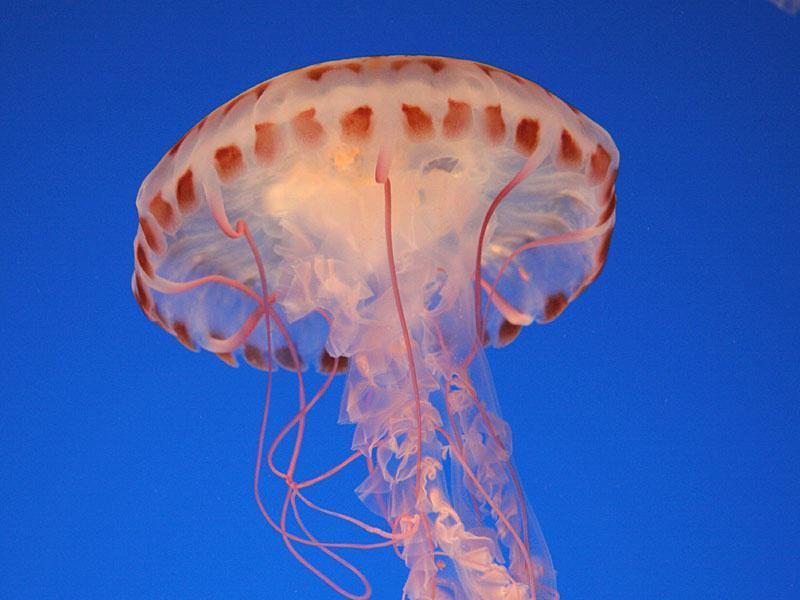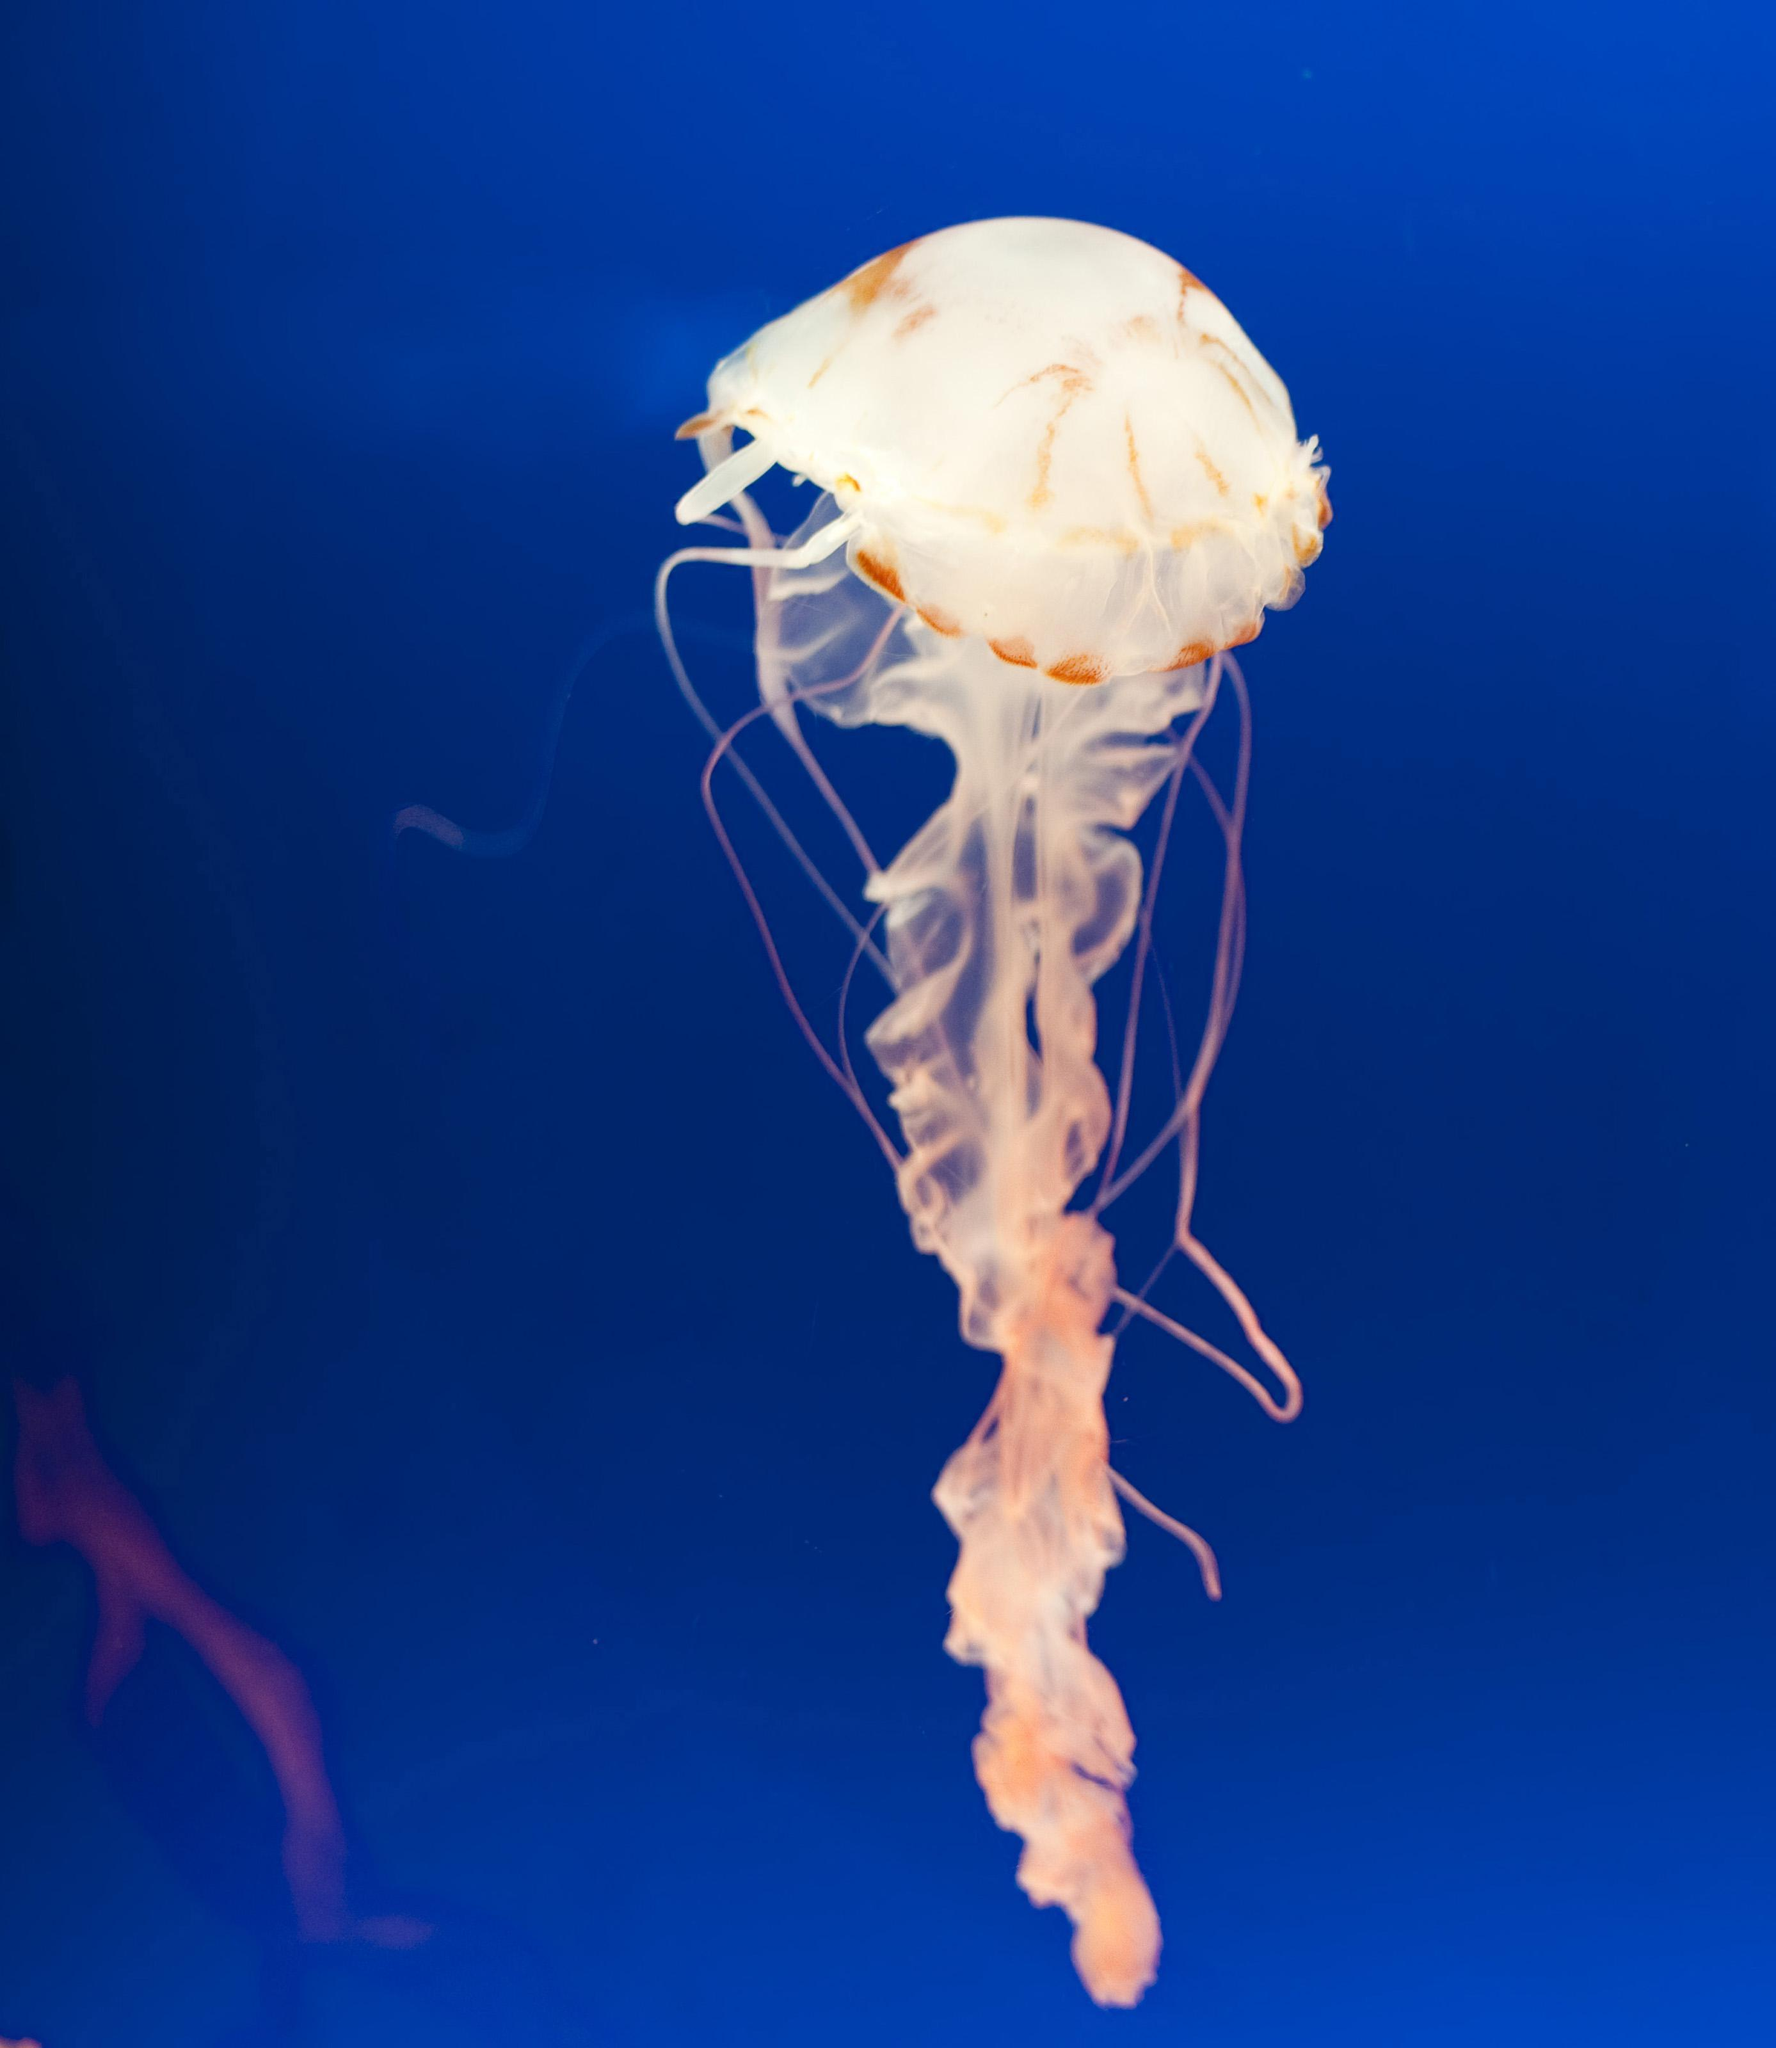The first image is the image on the left, the second image is the image on the right. For the images displayed, is the sentence "The jellyfish are all swimming up with their tentacles trailing under them." factually correct? Answer yes or no. Yes. The first image is the image on the left, the second image is the image on the right. Considering the images on both sides, is "the left pic has more then three creatures" valid? Answer yes or no. No. 